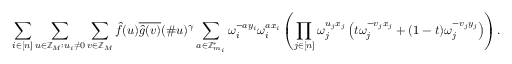<formula> <loc_0><loc_0><loc_500><loc_500>\sum _ { i \in [ n ] } \sum _ { u \in \mathbb { Z } _ { M } \colon u _ { i } \neq 0 } \sum _ { v \in \mathbb { Z } _ { M } } \hat { f } ( u ) \overline { { \hat { g } ( v ) } } ( \# u ) ^ { \gamma } \sum _ { a \in \mathbb { Z } _ { m _ { i } } ^ { * } } \omega _ { i } ^ { - a y _ { i } } \omega _ { i } ^ { a x _ { i } } \left ( \prod _ { j \in [ n ] } \omega _ { j } ^ { u _ { j } x _ { j } } \left ( t \omega _ { j } ^ { - v _ { j } x _ { j } } + ( 1 - t ) \omega _ { j } ^ { - v _ { j } y _ { j } } \right ) \right ) .</formula> 